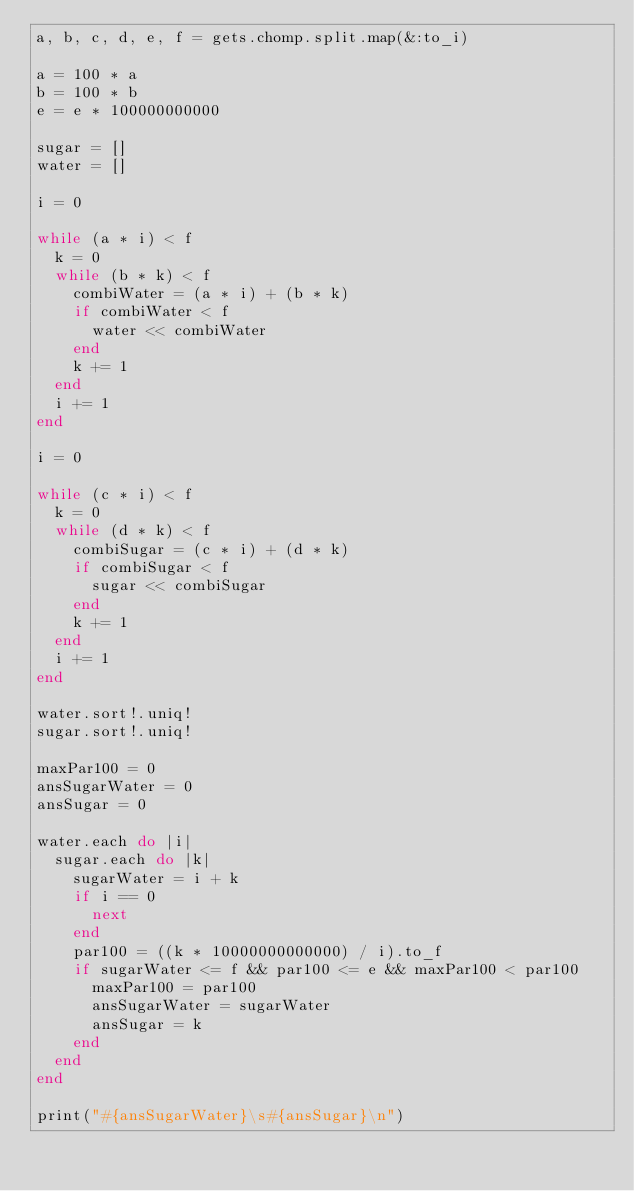<code> <loc_0><loc_0><loc_500><loc_500><_Ruby_>a, b, c, d, e, f = gets.chomp.split.map(&:to_i)

a = 100 * a 
b = 100 * b
e = e * 100000000000

sugar = []
water = []

i = 0

while (a * i) < f
  k = 0
  while (b * k) < f
    combiWater = (a * i) + (b * k)
    if combiWater < f
      water << combiWater
    end
    k += 1
  end
  i += 1
end

i = 0

while (c * i) < f
  k = 0
  while (d * k) < f
    combiSugar = (c * i) + (d * k)
    if combiSugar < f
      sugar << combiSugar
    end
    k += 1
  end
  i += 1
end

water.sort!.uniq!
sugar.sort!.uniq!

maxPar100 = 0
ansSugarWater = 0
ansSugar = 0

water.each do |i|
  sugar.each do |k|
    sugarWater = i + k
    if i == 0
      next
    end
    par100 = ((k * 10000000000000) / i).to_f
    if sugarWater <= f && par100 <= e && maxPar100 < par100
      maxPar100 = par100
      ansSugarWater = sugarWater
      ansSugar = k
    end
  end
end

print("#{ansSugarWater}\s#{ansSugar}\n")</code> 